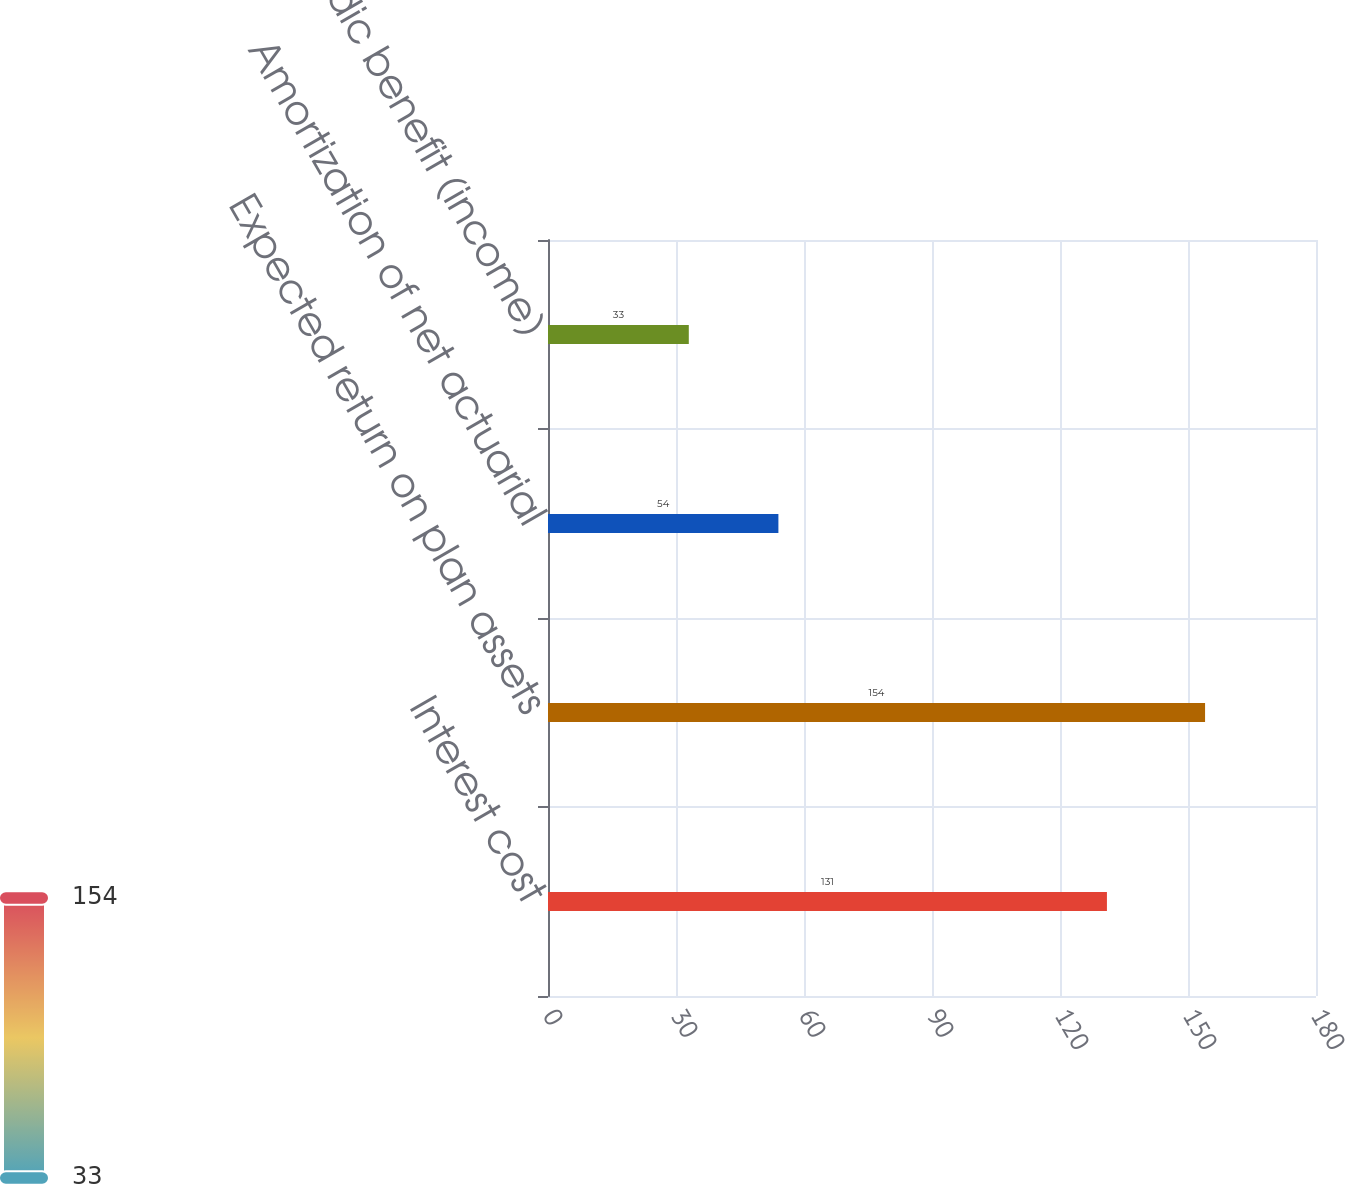Convert chart. <chart><loc_0><loc_0><loc_500><loc_500><bar_chart><fcel>Interest cost<fcel>Expected return on plan assets<fcel>Amortization of net actuarial<fcel>Net periodic benefit (income)<nl><fcel>131<fcel>154<fcel>54<fcel>33<nl></chart> 